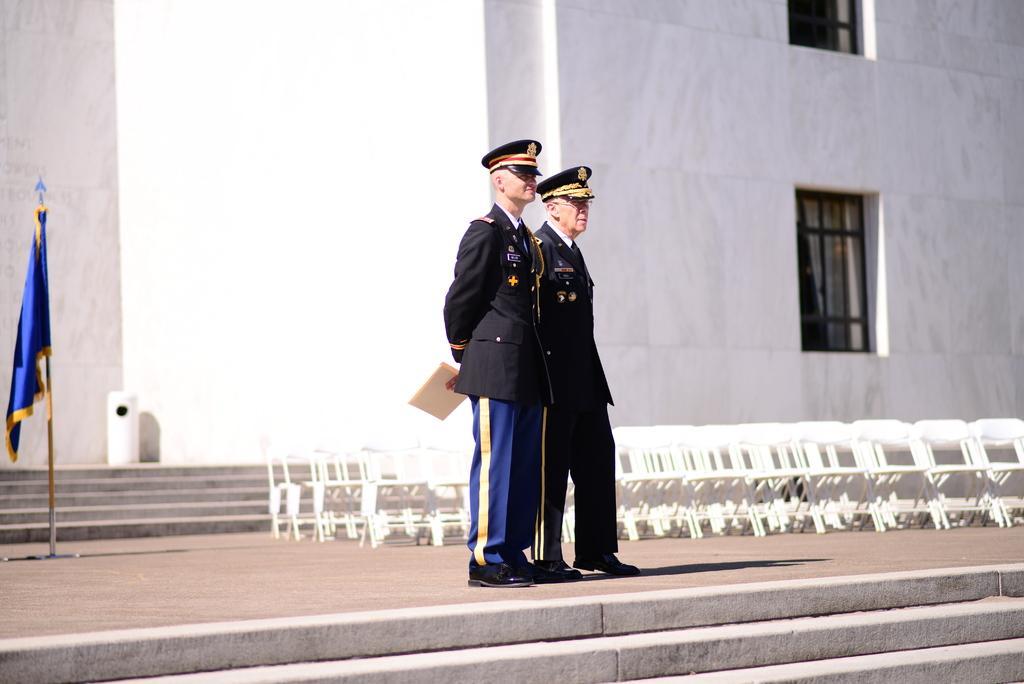Can you describe this image briefly? In this image we can see there are two persons standing on the ground and holding a paper, in front of them we can see the stairs. In the background, we can see the chairs, flag, wall with windows, stairs and the white color object. 